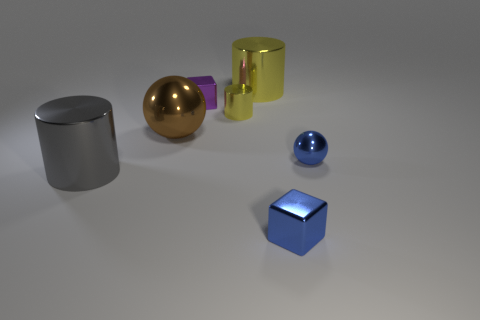What is the shape of the large gray metal object on the left side of the blue ball?
Your answer should be very brief. Cylinder. Does the block in front of the big brown sphere have the same color as the small ball?
Give a very brief answer. Yes. Is the number of tiny yellow things in front of the small blue ball less than the number of big brown metal objects?
Ensure brevity in your answer.  Yes. There is another tiny cube that is made of the same material as the purple block; what color is it?
Your answer should be very brief. Blue. There is a metal ball in front of the brown shiny object; how big is it?
Offer a very short reply. Small. Is there a yellow cylinder behind the metal cube that is behind the shiny ball right of the brown ball?
Your answer should be compact. Yes. What is the color of the large shiny ball?
Give a very brief answer. Brown. There is another metallic block that is the same size as the purple cube; what color is it?
Your answer should be very brief. Blue. There is a large metallic object that is to the right of the purple shiny block; is its shape the same as the big gray object?
Offer a very short reply. Yes. There is a metallic cylinder that is on the left side of the small block behind the small cube that is in front of the brown shiny thing; what is its color?
Keep it short and to the point. Gray. 